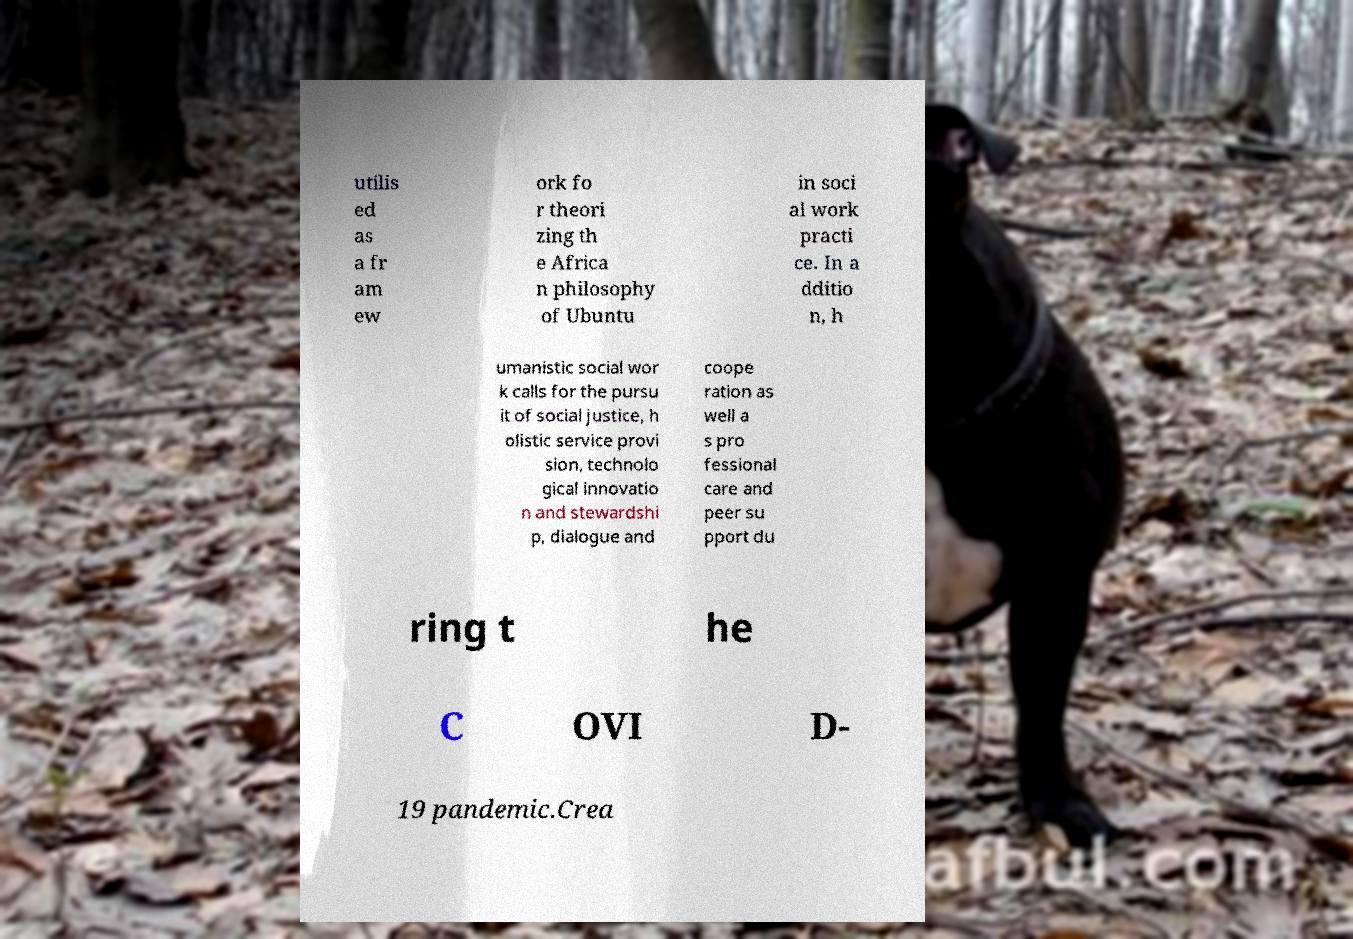I need the written content from this picture converted into text. Can you do that? utilis ed as a fr am ew ork fo r theori zing th e Africa n philosophy of Ubuntu in soci al work practi ce. In a dditio n, h umanistic social wor k calls for the pursu it of social justice, h olistic service provi sion, technolo gical innovatio n and stewardshi p, dialogue and coope ration as well a s pro fessional care and peer su pport du ring t he C OVI D- 19 pandemic.Crea 